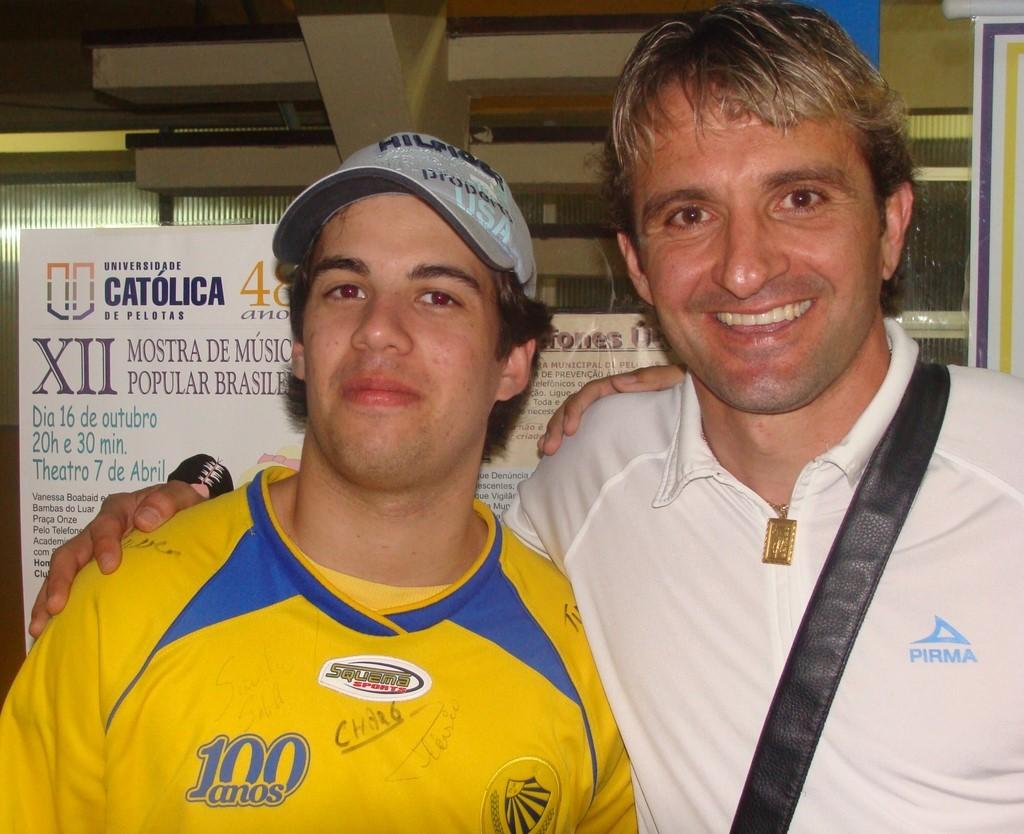<image>
Present a compact description of the photo's key features. a couple guys side by side and one with the numbers 100 on him 